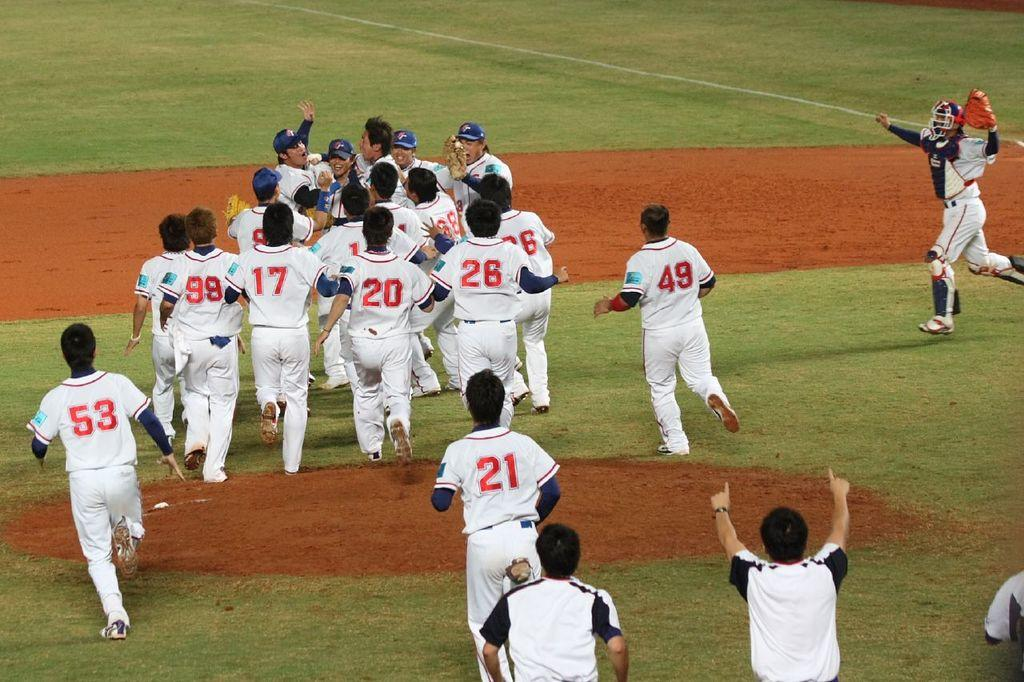<image>
Describe the image concisely. Baseball players with numbers such as 53, 21, 26, 20, 17, etc. are running out onto a field. 